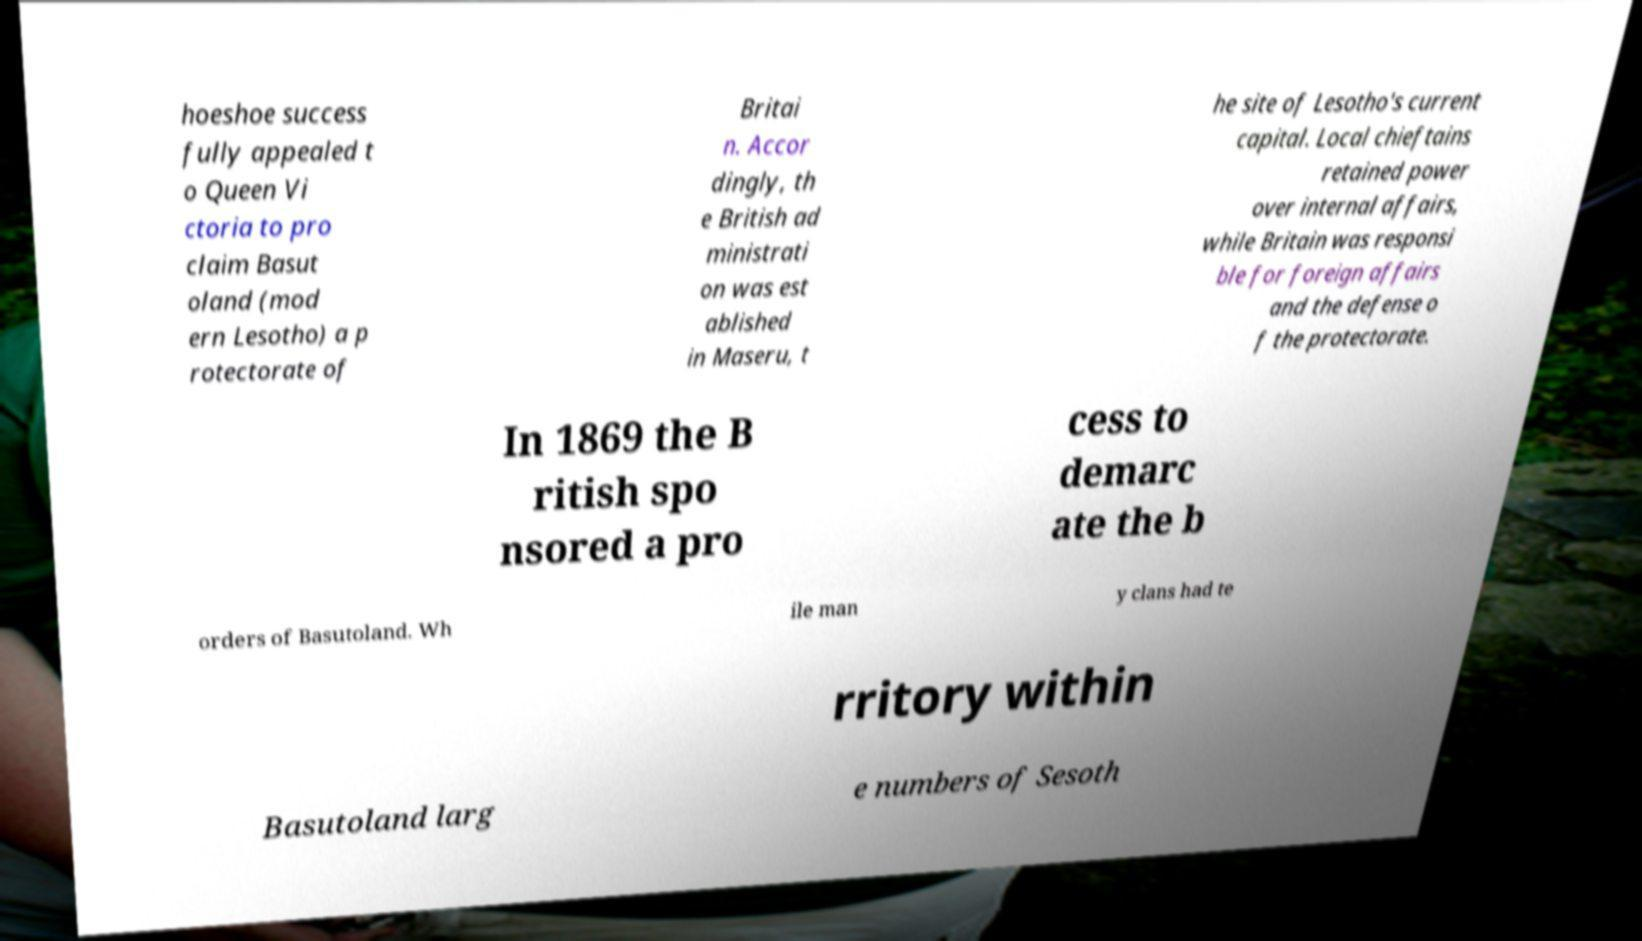Please read and relay the text visible in this image. What does it say? hoeshoe success fully appealed t o Queen Vi ctoria to pro claim Basut oland (mod ern Lesotho) a p rotectorate of Britai n. Accor dingly, th e British ad ministrati on was est ablished in Maseru, t he site of Lesotho's current capital. Local chieftains retained power over internal affairs, while Britain was responsi ble for foreign affairs and the defense o f the protectorate. In 1869 the B ritish spo nsored a pro cess to demarc ate the b orders of Basutoland. Wh ile man y clans had te rritory within Basutoland larg e numbers of Sesoth 